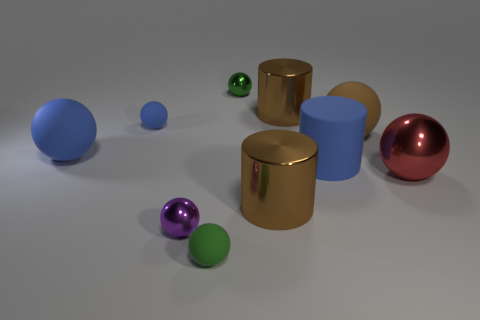Subtract all green balls. How many balls are left? 5 Subtract all red balls. How many balls are left? 6 Subtract 3 spheres. How many spheres are left? 4 Subtract all blue balls. Subtract all gray cylinders. How many balls are left? 5 Subtract all balls. How many objects are left? 3 Subtract all small green balls. Subtract all brown things. How many objects are left? 5 Add 4 blue rubber cylinders. How many blue rubber cylinders are left? 5 Add 3 green metal things. How many green metal things exist? 4 Subtract 0 green cubes. How many objects are left? 10 